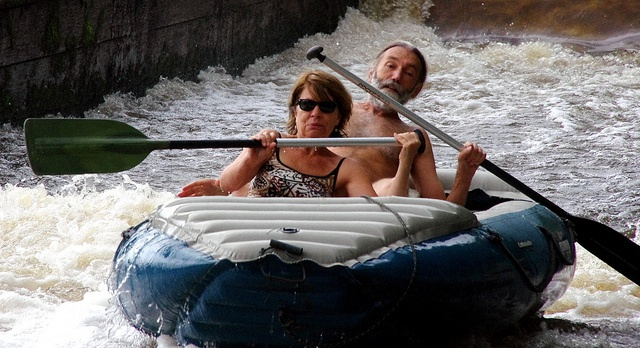Describe the objects in this image and their specific colors. I can see boat in black, darkgray, lightgray, and gray tones, people in black, maroon, brown, and gray tones, and people in black, maroon, and brown tones in this image. 